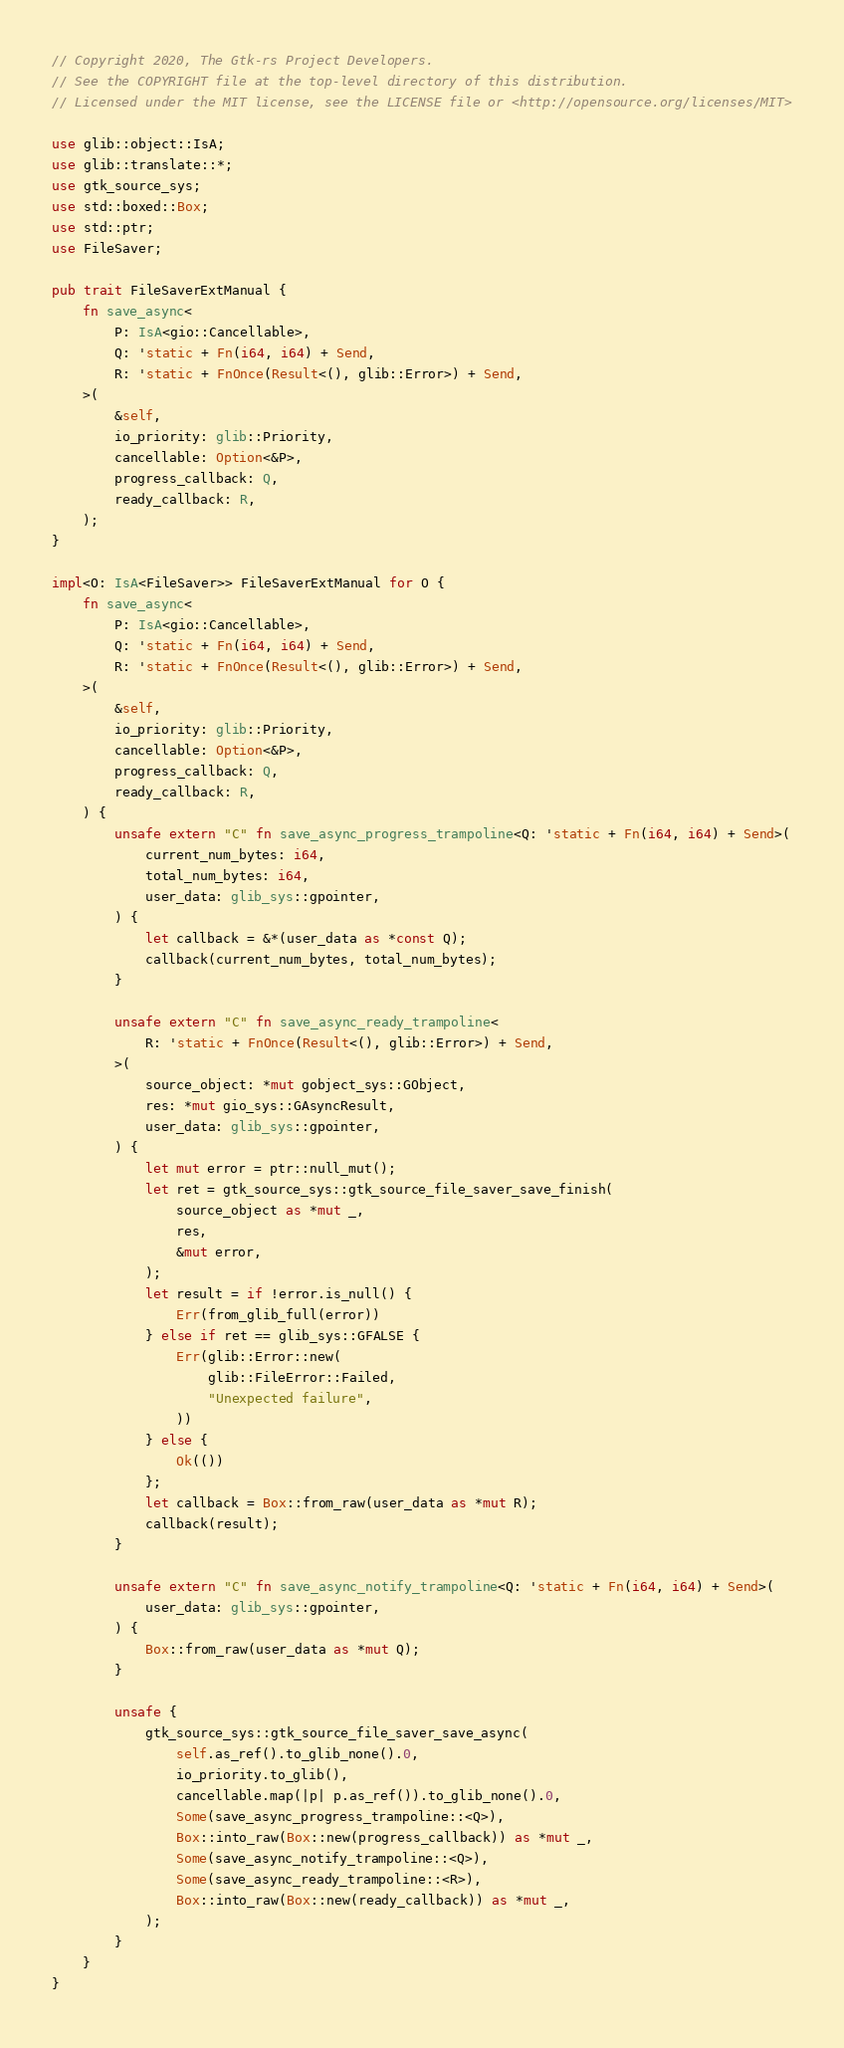Convert code to text. <code><loc_0><loc_0><loc_500><loc_500><_Rust_>// Copyright 2020, The Gtk-rs Project Developers.
// See the COPYRIGHT file at the top-level directory of this distribution.
// Licensed under the MIT license, see the LICENSE file or <http://opensource.org/licenses/MIT>

use glib::object::IsA;
use glib::translate::*;
use gtk_source_sys;
use std::boxed::Box;
use std::ptr;
use FileSaver;

pub trait FileSaverExtManual {
    fn save_async<
        P: IsA<gio::Cancellable>,
        Q: 'static + Fn(i64, i64) + Send,
        R: 'static + FnOnce(Result<(), glib::Error>) + Send,
    >(
        &self,
        io_priority: glib::Priority,
        cancellable: Option<&P>,
        progress_callback: Q,
        ready_callback: R,
    );
}

impl<O: IsA<FileSaver>> FileSaverExtManual for O {
    fn save_async<
        P: IsA<gio::Cancellable>,
        Q: 'static + Fn(i64, i64) + Send,
        R: 'static + FnOnce(Result<(), glib::Error>) + Send,
    >(
        &self,
        io_priority: glib::Priority,
        cancellable: Option<&P>,
        progress_callback: Q,
        ready_callback: R,
    ) {
        unsafe extern "C" fn save_async_progress_trampoline<Q: 'static + Fn(i64, i64) + Send>(
            current_num_bytes: i64,
            total_num_bytes: i64,
            user_data: glib_sys::gpointer,
        ) {
            let callback = &*(user_data as *const Q);
            callback(current_num_bytes, total_num_bytes);
        }

        unsafe extern "C" fn save_async_ready_trampoline<
            R: 'static + FnOnce(Result<(), glib::Error>) + Send,
        >(
            source_object: *mut gobject_sys::GObject,
            res: *mut gio_sys::GAsyncResult,
            user_data: glib_sys::gpointer,
        ) {
            let mut error = ptr::null_mut();
            let ret = gtk_source_sys::gtk_source_file_saver_save_finish(
                source_object as *mut _,
                res,
                &mut error,
            );
            let result = if !error.is_null() {
                Err(from_glib_full(error))
            } else if ret == glib_sys::GFALSE {
                Err(glib::Error::new(
                    glib::FileError::Failed,
                    "Unexpected failure",
                ))
            } else {
                Ok(())
            };
            let callback = Box::from_raw(user_data as *mut R);
            callback(result);
        }

        unsafe extern "C" fn save_async_notify_trampoline<Q: 'static + Fn(i64, i64) + Send>(
            user_data: glib_sys::gpointer,
        ) {
            Box::from_raw(user_data as *mut Q);
        }

        unsafe {
            gtk_source_sys::gtk_source_file_saver_save_async(
                self.as_ref().to_glib_none().0,
                io_priority.to_glib(),
                cancellable.map(|p| p.as_ref()).to_glib_none().0,
                Some(save_async_progress_trampoline::<Q>),
                Box::into_raw(Box::new(progress_callback)) as *mut _,
                Some(save_async_notify_trampoline::<Q>),
                Some(save_async_ready_trampoline::<R>),
                Box::into_raw(Box::new(ready_callback)) as *mut _,
            );
        }
    }
}
</code> 